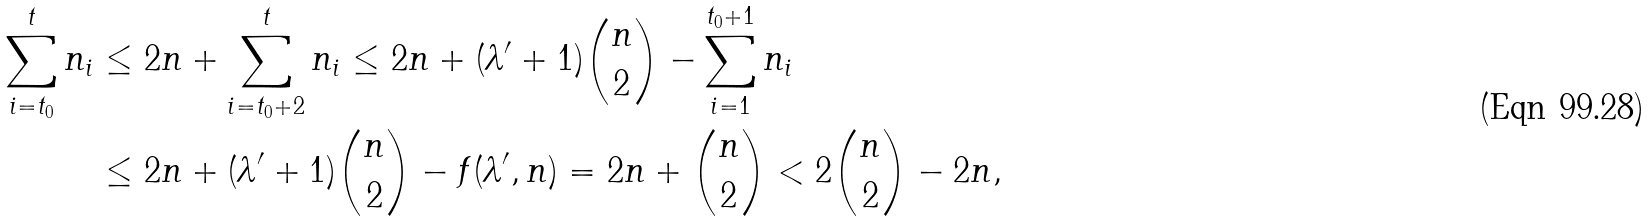<formula> <loc_0><loc_0><loc_500><loc_500>\sum _ { i = t _ { 0 } } ^ { t } n _ { i } & \leq 2 n + \sum _ { i = t _ { 0 } + 2 } ^ { t } n _ { i } \leq 2 n + ( \lambda ^ { \prime } + 1 ) \binom { n } { 2 } - \sum _ { i = 1 } ^ { t _ { 0 } + 1 } n _ { i } \\ & \leq 2 n + ( \lambda ^ { \prime } + 1 ) \binom { n } { 2 } - f ( \lambda ^ { \prime } , n ) = 2 n + \binom { n } { 2 } < 2 \binom { n } { 2 } - 2 n ,</formula> 